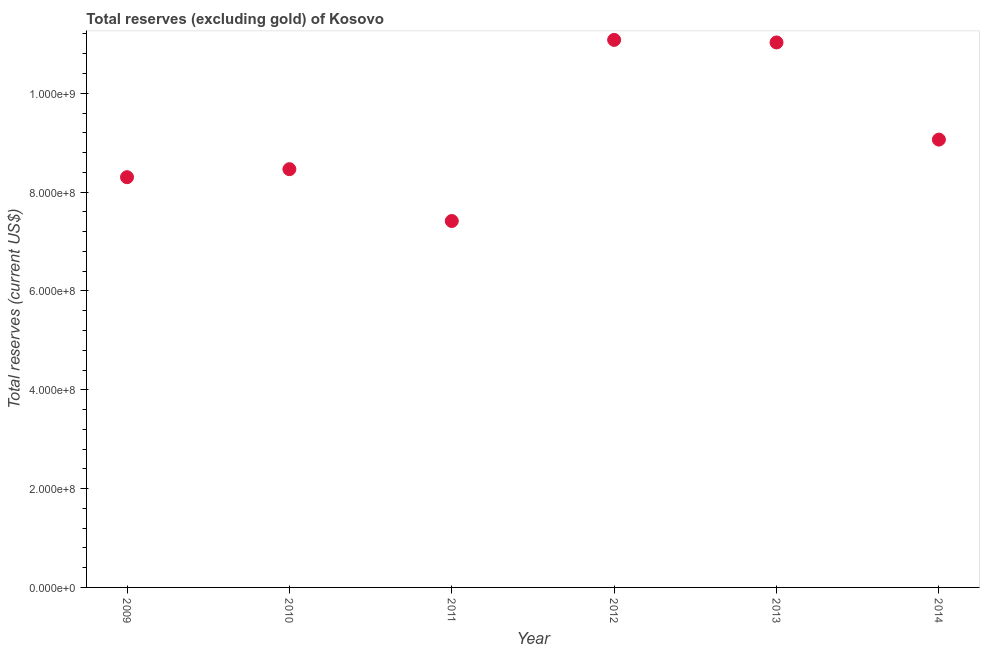What is the total reserves (excluding gold) in 2009?
Ensure brevity in your answer.  8.30e+08. Across all years, what is the maximum total reserves (excluding gold)?
Provide a short and direct response. 1.11e+09. Across all years, what is the minimum total reserves (excluding gold)?
Offer a terse response. 7.42e+08. What is the sum of the total reserves (excluding gold)?
Offer a terse response. 5.54e+09. What is the difference between the total reserves (excluding gold) in 2009 and 2013?
Your answer should be very brief. -2.73e+08. What is the average total reserves (excluding gold) per year?
Your response must be concise. 9.23e+08. What is the median total reserves (excluding gold)?
Your answer should be compact. 8.76e+08. What is the ratio of the total reserves (excluding gold) in 2010 to that in 2011?
Your answer should be compact. 1.14. What is the difference between the highest and the second highest total reserves (excluding gold)?
Give a very brief answer. 5.18e+06. Is the sum of the total reserves (excluding gold) in 2009 and 2010 greater than the maximum total reserves (excluding gold) across all years?
Your response must be concise. Yes. What is the difference between the highest and the lowest total reserves (excluding gold)?
Provide a succinct answer. 3.67e+08. How many years are there in the graph?
Offer a very short reply. 6. What is the difference between two consecutive major ticks on the Y-axis?
Give a very brief answer. 2.00e+08. Does the graph contain any zero values?
Keep it short and to the point. No. Does the graph contain grids?
Your answer should be compact. No. What is the title of the graph?
Give a very brief answer. Total reserves (excluding gold) of Kosovo. What is the label or title of the Y-axis?
Keep it short and to the point. Total reserves (current US$). What is the Total reserves (current US$) in 2009?
Provide a short and direct response. 8.30e+08. What is the Total reserves (current US$) in 2010?
Keep it short and to the point. 8.46e+08. What is the Total reserves (current US$) in 2011?
Your answer should be very brief. 7.42e+08. What is the Total reserves (current US$) in 2012?
Your response must be concise. 1.11e+09. What is the Total reserves (current US$) in 2013?
Your answer should be compact. 1.10e+09. What is the Total reserves (current US$) in 2014?
Make the answer very short. 9.06e+08. What is the difference between the Total reserves (current US$) in 2009 and 2010?
Provide a succinct answer. -1.62e+07. What is the difference between the Total reserves (current US$) in 2009 and 2011?
Your answer should be very brief. 8.87e+07. What is the difference between the Total reserves (current US$) in 2009 and 2012?
Make the answer very short. -2.78e+08. What is the difference between the Total reserves (current US$) in 2009 and 2013?
Offer a terse response. -2.73e+08. What is the difference between the Total reserves (current US$) in 2009 and 2014?
Your response must be concise. -7.61e+07. What is the difference between the Total reserves (current US$) in 2010 and 2011?
Provide a succinct answer. 1.05e+08. What is the difference between the Total reserves (current US$) in 2010 and 2012?
Provide a succinct answer. -2.62e+08. What is the difference between the Total reserves (current US$) in 2010 and 2013?
Provide a succinct answer. -2.57e+08. What is the difference between the Total reserves (current US$) in 2010 and 2014?
Offer a terse response. -5.99e+07. What is the difference between the Total reserves (current US$) in 2011 and 2012?
Make the answer very short. -3.67e+08. What is the difference between the Total reserves (current US$) in 2011 and 2013?
Offer a terse response. -3.61e+08. What is the difference between the Total reserves (current US$) in 2011 and 2014?
Provide a succinct answer. -1.65e+08. What is the difference between the Total reserves (current US$) in 2012 and 2013?
Make the answer very short. 5.18e+06. What is the difference between the Total reserves (current US$) in 2012 and 2014?
Provide a succinct answer. 2.02e+08. What is the difference between the Total reserves (current US$) in 2013 and 2014?
Give a very brief answer. 1.97e+08. What is the ratio of the Total reserves (current US$) in 2009 to that in 2011?
Offer a terse response. 1.12. What is the ratio of the Total reserves (current US$) in 2009 to that in 2012?
Ensure brevity in your answer.  0.75. What is the ratio of the Total reserves (current US$) in 2009 to that in 2013?
Your response must be concise. 0.75. What is the ratio of the Total reserves (current US$) in 2009 to that in 2014?
Your answer should be compact. 0.92. What is the ratio of the Total reserves (current US$) in 2010 to that in 2011?
Ensure brevity in your answer.  1.14. What is the ratio of the Total reserves (current US$) in 2010 to that in 2012?
Your answer should be compact. 0.76. What is the ratio of the Total reserves (current US$) in 2010 to that in 2013?
Offer a very short reply. 0.77. What is the ratio of the Total reserves (current US$) in 2010 to that in 2014?
Offer a very short reply. 0.93. What is the ratio of the Total reserves (current US$) in 2011 to that in 2012?
Make the answer very short. 0.67. What is the ratio of the Total reserves (current US$) in 2011 to that in 2013?
Your response must be concise. 0.67. What is the ratio of the Total reserves (current US$) in 2011 to that in 2014?
Give a very brief answer. 0.82. What is the ratio of the Total reserves (current US$) in 2012 to that in 2014?
Offer a very short reply. 1.22. What is the ratio of the Total reserves (current US$) in 2013 to that in 2014?
Provide a short and direct response. 1.22. 